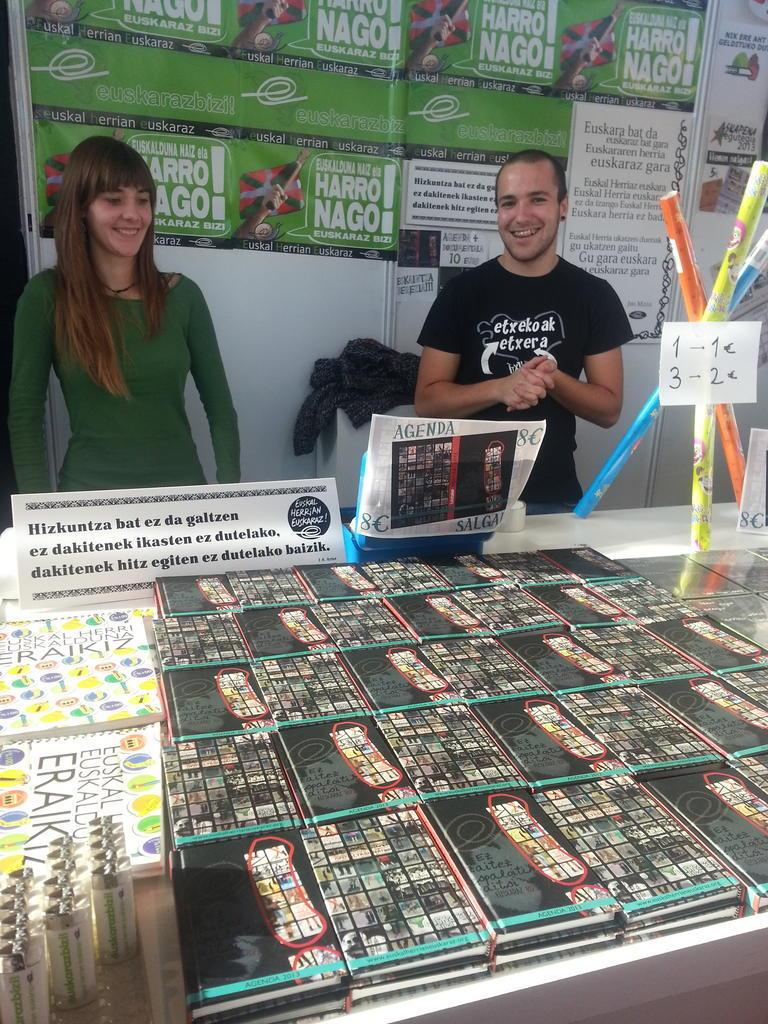How many people are in the image? There are two people in the image. What are the people doing in the image? The people are standing in front of a table. What items can be seen on the table? There are books, boards, and other things placed on the table. What is visible in the background of the image? There are banners visible in the background. What type of watch is the person wearing in the image? There is no watch visible on either person in the image. What are the people learning from the books and boards on the table? The image does not provide any information about what the people might be learning from the books and boards on the table. 